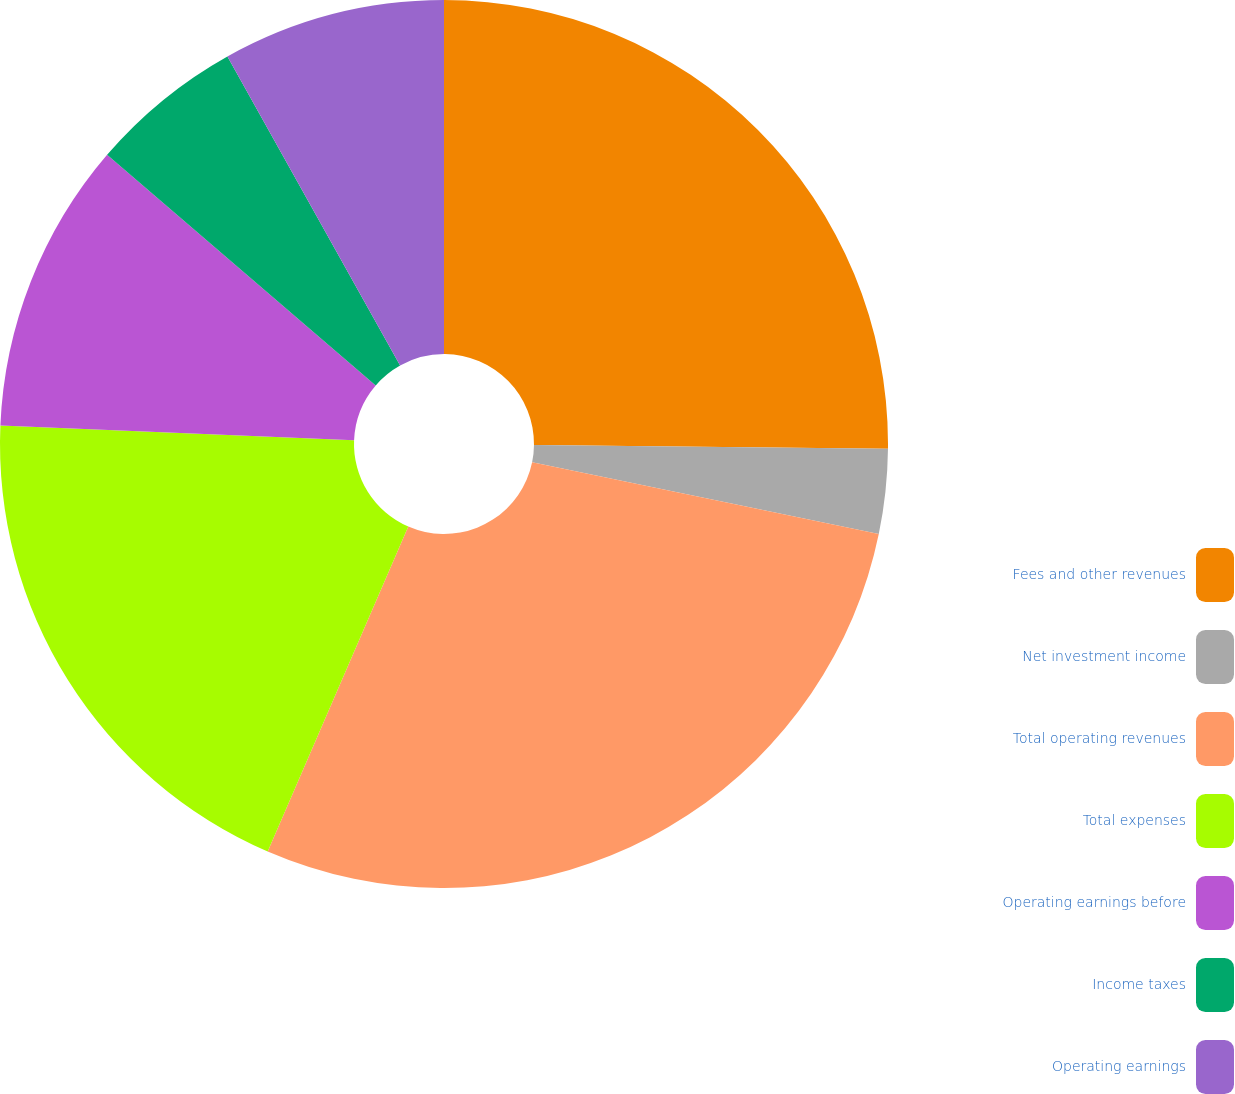Convert chart. <chart><loc_0><loc_0><loc_500><loc_500><pie_chart><fcel>Fees and other revenues<fcel>Net investment income<fcel>Total operating revenues<fcel>Total expenses<fcel>Operating earnings before<fcel>Income taxes<fcel>Operating earnings<nl><fcel>25.17%<fcel>3.08%<fcel>28.25%<fcel>19.16%<fcel>10.63%<fcel>5.6%<fcel>8.11%<nl></chart> 